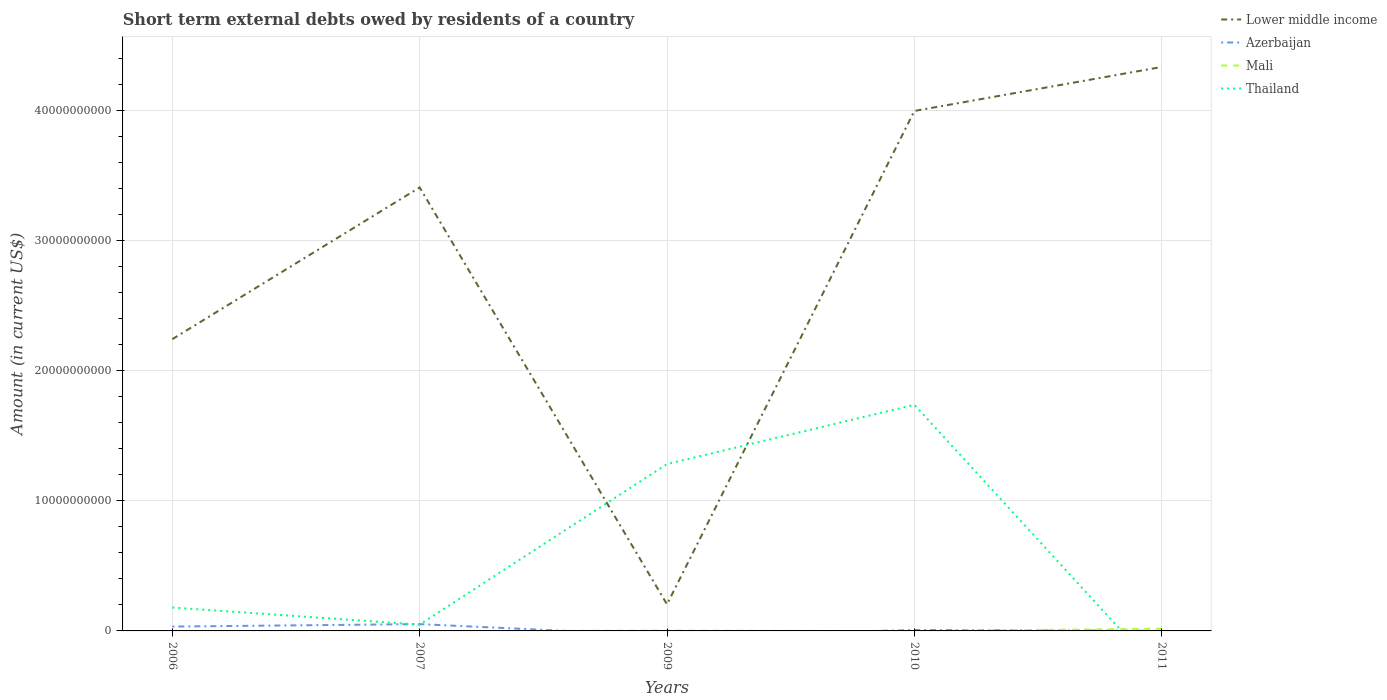How many different coloured lines are there?
Provide a short and direct response. 4. Does the line corresponding to Azerbaijan intersect with the line corresponding to Lower middle income?
Ensure brevity in your answer.  No. Is the number of lines equal to the number of legend labels?
Your answer should be compact. No. What is the total amount of short-term external debts owed by residents in Lower middle income in the graph?
Offer a terse response. 2.04e+1. What is the difference between the highest and the second highest amount of short-term external debts owed by residents in Lower middle income?
Offer a terse response. 4.13e+1. How many lines are there?
Keep it short and to the point. 4. How many years are there in the graph?
Make the answer very short. 5. Are the values on the major ticks of Y-axis written in scientific E-notation?
Offer a very short reply. No. Does the graph contain any zero values?
Your answer should be compact. Yes. How are the legend labels stacked?
Your response must be concise. Vertical. What is the title of the graph?
Your answer should be compact. Short term external debts owed by residents of a country. What is the label or title of the X-axis?
Give a very brief answer. Years. What is the label or title of the Y-axis?
Keep it short and to the point. Amount (in current US$). What is the Amount (in current US$) in Lower middle income in 2006?
Make the answer very short. 2.24e+1. What is the Amount (in current US$) in Azerbaijan in 2006?
Your answer should be compact. 3.34e+08. What is the Amount (in current US$) in Thailand in 2006?
Your answer should be compact. 1.80e+09. What is the Amount (in current US$) in Lower middle income in 2007?
Ensure brevity in your answer.  3.41e+1. What is the Amount (in current US$) of Azerbaijan in 2007?
Offer a very short reply. 5.23e+08. What is the Amount (in current US$) of Thailand in 2007?
Ensure brevity in your answer.  4.83e+08. What is the Amount (in current US$) in Lower middle income in 2009?
Provide a succinct answer. 2.04e+09. What is the Amount (in current US$) in Mali in 2009?
Provide a short and direct response. 2.40e+07. What is the Amount (in current US$) in Thailand in 2009?
Offer a very short reply. 1.28e+1. What is the Amount (in current US$) in Lower middle income in 2010?
Offer a very short reply. 4.00e+1. What is the Amount (in current US$) in Azerbaijan in 2010?
Keep it short and to the point. 6.80e+07. What is the Amount (in current US$) of Mali in 2010?
Give a very brief answer. 0. What is the Amount (in current US$) of Thailand in 2010?
Offer a terse response. 1.74e+1. What is the Amount (in current US$) of Lower middle income in 2011?
Give a very brief answer. 4.33e+1. What is the Amount (in current US$) of Azerbaijan in 2011?
Your answer should be very brief. 1.30e+07. What is the Amount (in current US$) in Mali in 2011?
Offer a very short reply. 1.69e+08. Across all years, what is the maximum Amount (in current US$) of Lower middle income?
Make the answer very short. 4.33e+1. Across all years, what is the maximum Amount (in current US$) of Azerbaijan?
Provide a succinct answer. 5.23e+08. Across all years, what is the maximum Amount (in current US$) in Mali?
Your answer should be compact. 1.69e+08. Across all years, what is the maximum Amount (in current US$) in Thailand?
Provide a succinct answer. 1.74e+1. Across all years, what is the minimum Amount (in current US$) of Lower middle income?
Your answer should be very brief. 2.04e+09. Across all years, what is the minimum Amount (in current US$) in Mali?
Offer a very short reply. 0. Across all years, what is the minimum Amount (in current US$) of Thailand?
Your response must be concise. 0. What is the total Amount (in current US$) of Lower middle income in the graph?
Your answer should be very brief. 1.42e+11. What is the total Amount (in current US$) in Azerbaijan in the graph?
Ensure brevity in your answer.  9.38e+08. What is the total Amount (in current US$) in Mali in the graph?
Give a very brief answer. 1.93e+08. What is the total Amount (in current US$) in Thailand in the graph?
Your answer should be very brief. 3.25e+1. What is the difference between the Amount (in current US$) of Lower middle income in 2006 and that in 2007?
Provide a succinct answer. -1.17e+1. What is the difference between the Amount (in current US$) of Azerbaijan in 2006 and that in 2007?
Your answer should be very brief. -1.89e+08. What is the difference between the Amount (in current US$) in Thailand in 2006 and that in 2007?
Provide a short and direct response. 1.32e+09. What is the difference between the Amount (in current US$) of Lower middle income in 2006 and that in 2009?
Provide a succinct answer. 2.04e+1. What is the difference between the Amount (in current US$) in Thailand in 2006 and that in 2009?
Offer a terse response. -1.10e+1. What is the difference between the Amount (in current US$) of Lower middle income in 2006 and that in 2010?
Make the answer very short. -1.75e+1. What is the difference between the Amount (in current US$) in Azerbaijan in 2006 and that in 2010?
Ensure brevity in your answer.  2.66e+08. What is the difference between the Amount (in current US$) in Thailand in 2006 and that in 2010?
Give a very brief answer. -1.56e+1. What is the difference between the Amount (in current US$) of Lower middle income in 2006 and that in 2011?
Provide a short and direct response. -2.09e+1. What is the difference between the Amount (in current US$) in Azerbaijan in 2006 and that in 2011?
Offer a terse response. 3.21e+08. What is the difference between the Amount (in current US$) in Lower middle income in 2007 and that in 2009?
Your response must be concise. 3.20e+1. What is the difference between the Amount (in current US$) in Thailand in 2007 and that in 2009?
Make the answer very short. -1.23e+1. What is the difference between the Amount (in current US$) of Lower middle income in 2007 and that in 2010?
Give a very brief answer. -5.88e+09. What is the difference between the Amount (in current US$) in Azerbaijan in 2007 and that in 2010?
Make the answer very short. 4.55e+08. What is the difference between the Amount (in current US$) in Thailand in 2007 and that in 2010?
Your answer should be compact. -1.69e+1. What is the difference between the Amount (in current US$) of Lower middle income in 2007 and that in 2011?
Keep it short and to the point. -9.26e+09. What is the difference between the Amount (in current US$) of Azerbaijan in 2007 and that in 2011?
Make the answer very short. 5.10e+08. What is the difference between the Amount (in current US$) of Lower middle income in 2009 and that in 2010?
Offer a very short reply. -3.79e+1. What is the difference between the Amount (in current US$) in Thailand in 2009 and that in 2010?
Provide a short and direct response. -4.55e+09. What is the difference between the Amount (in current US$) of Lower middle income in 2009 and that in 2011?
Your answer should be very brief. -4.13e+1. What is the difference between the Amount (in current US$) of Mali in 2009 and that in 2011?
Offer a very short reply. -1.45e+08. What is the difference between the Amount (in current US$) of Lower middle income in 2010 and that in 2011?
Give a very brief answer. -3.38e+09. What is the difference between the Amount (in current US$) in Azerbaijan in 2010 and that in 2011?
Your answer should be very brief. 5.50e+07. What is the difference between the Amount (in current US$) of Lower middle income in 2006 and the Amount (in current US$) of Azerbaijan in 2007?
Provide a succinct answer. 2.19e+1. What is the difference between the Amount (in current US$) in Lower middle income in 2006 and the Amount (in current US$) in Thailand in 2007?
Your answer should be very brief. 2.19e+1. What is the difference between the Amount (in current US$) in Azerbaijan in 2006 and the Amount (in current US$) in Thailand in 2007?
Provide a succinct answer. -1.49e+08. What is the difference between the Amount (in current US$) in Lower middle income in 2006 and the Amount (in current US$) in Mali in 2009?
Keep it short and to the point. 2.24e+1. What is the difference between the Amount (in current US$) in Lower middle income in 2006 and the Amount (in current US$) in Thailand in 2009?
Provide a short and direct response. 9.60e+09. What is the difference between the Amount (in current US$) in Azerbaijan in 2006 and the Amount (in current US$) in Mali in 2009?
Ensure brevity in your answer.  3.10e+08. What is the difference between the Amount (in current US$) of Azerbaijan in 2006 and the Amount (in current US$) of Thailand in 2009?
Your answer should be very brief. -1.25e+1. What is the difference between the Amount (in current US$) in Lower middle income in 2006 and the Amount (in current US$) in Azerbaijan in 2010?
Give a very brief answer. 2.24e+1. What is the difference between the Amount (in current US$) in Lower middle income in 2006 and the Amount (in current US$) in Thailand in 2010?
Give a very brief answer. 5.05e+09. What is the difference between the Amount (in current US$) in Azerbaijan in 2006 and the Amount (in current US$) in Thailand in 2010?
Offer a very short reply. -1.70e+1. What is the difference between the Amount (in current US$) of Lower middle income in 2006 and the Amount (in current US$) of Azerbaijan in 2011?
Provide a succinct answer. 2.24e+1. What is the difference between the Amount (in current US$) in Lower middle income in 2006 and the Amount (in current US$) in Mali in 2011?
Provide a short and direct response. 2.23e+1. What is the difference between the Amount (in current US$) in Azerbaijan in 2006 and the Amount (in current US$) in Mali in 2011?
Your answer should be very brief. 1.65e+08. What is the difference between the Amount (in current US$) of Lower middle income in 2007 and the Amount (in current US$) of Mali in 2009?
Provide a succinct answer. 3.41e+1. What is the difference between the Amount (in current US$) of Lower middle income in 2007 and the Amount (in current US$) of Thailand in 2009?
Ensure brevity in your answer.  2.13e+1. What is the difference between the Amount (in current US$) of Azerbaijan in 2007 and the Amount (in current US$) of Mali in 2009?
Give a very brief answer. 4.99e+08. What is the difference between the Amount (in current US$) of Azerbaijan in 2007 and the Amount (in current US$) of Thailand in 2009?
Provide a succinct answer. -1.23e+1. What is the difference between the Amount (in current US$) of Lower middle income in 2007 and the Amount (in current US$) of Azerbaijan in 2010?
Your answer should be compact. 3.40e+1. What is the difference between the Amount (in current US$) in Lower middle income in 2007 and the Amount (in current US$) in Thailand in 2010?
Ensure brevity in your answer.  1.67e+1. What is the difference between the Amount (in current US$) of Azerbaijan in 2007 and the Amount (in current US$) of Thailand in 2010?
Give a very brief answer. -1.69e+1. What is the difference between the Amount (in current US$) of Lower middle income in 2007 and the Amount (in current US$) of Azerbaijan in 2011?
Your answer should be compact. 3.41e+1. What is the difference between the Amount (in current US$) in Lower middle income in 2007 and the Amount (in current US$) in Mali in 2011?
Offer a terse response. 3.39e+1. What is the difference between the Amount (in current US$) of Azerbaijan in 2007 and the Amount (in current US$) of Mali in 2011?
Offer a terse response. 3.54e+08. What is the difference between the Amount (in current US$) in Lower middle income in 2009 and the Amount (in current US$) in Azerbaijan in 2010?
Provide a short and direct response. 1.97e+09. What is the difference between the Amount (in current US$) of Lower middle income in 2009 and the Amount (in current US$) of Thailand in 2010?
Give a very brief answer. -1.53e+1. What is the difference between the Amount (in current US$) of Mali in 2009 and the Amount (in current US$) of Thailand in 2010?
Ensure brevity in your answer.  -1.74e+1. What is the difference between the Amount (in current US$) in Lower middle income in 2009 and the Amount (in current US$) in Azerbaijan in 2011?
Give a very brief answer. 2.03e+09. What is the difference between the Amount (in current US$) in Lower middle income in 2009 and the Amount (in current US$) in Mali in 2011?
Your answer should be compact. 1.87e+09. What is the difference between the Amount (in current US$) of Lower middle income in 2010 and the Amount (in current US$) of Azerbaijan in 2011?
Ensure brevity in your answer.  4.00e+1. What is the difference between the Amount (in current US$) of Lower middle income in 2010 and the Amount (in current US$) of Mali in 2011?
Ensure brevity in your answer.  3.98e+1. What is the difference between the Amount (in current US$) in Azerbaijan in 2010 and the Amount (in current US$) in Mali in 2011?
Your response must be concise. -1.01e+08. What is the average Amount (in current US$) of Lower middle income per year?
Your response must be concise. 2.84e+1. What is the average Amount (in current US$) in Azerbaijan per year?
Your answer should be very brief. 1.88e+08. What is the average Amount (in current US$) in Mali per year?
Offer a terse response. 3.86e+07. What is the average Amount (in current US$) of Thailand per year?
Your answer should be very brief. 6.50e+09. In the year 2006, what is the difference between the Amount (in current US$) in Lower middle income and Amount (in current US$) in Azerbaijan?
Your answer should be very brief. 2.21e+1. In the year 2006, what is the difference between the Amount (in current US$) of Lower middle income and Amount (in current US$) of Thailand?
Provide a succinct answer. 2.06e+1. In the year 2006, what is the difference between the Amount (in current US$) of Azerbaijan and Amount (in current US$) of Thailand?
Ensure brevity in your answer.  -1.46e+09. In the year 2007, what is the difference between the Amount (in current US$) in Lower middle income and Amount (in current US$) in Azerbaijan?
Ensure brevity in your answer.  3.36e+1. In the year 2007, what is the difference between the Amount (in current US$) in Lower middle income and Amount (in current US$) in Thailand?
Provide a succinct answer. 3.36e+1. In the year 2007, what is the difference between the Amount (in current US$) of Azerbaijan and Amount (in current US$) of Thailand?
Your response must be concise. 4.00e+07. In the year 2009, what is the difference between the Amount (in current US$) in Lower middle income and Amount (in current US$) in Mali?
Ensure brevity in your answer.  2.02e+09. In the year 2009, what is the difference between the Amount (in current US$) of Lower middle income and Amount (in current US$) of Thailand?
Make the answer very short. -1.08e+1. In the year 2009, what is the difference between the Amount (in current US$) of Mali and Amount (in current US$) of Thailand?
Provide a succinct answer. -1.28e+1. In the year 2010, what is the difference between the Amount (in current US$) in Lower middle income and Amount (in current US$) in Azerbaijan?
Offer a terse response. 3.99e+1. In the year 2010, what is the difference between the Amount (in current US$) of Lower middle income and Amount (in current US$) of Thailand?
Your response must be concise. 2.26e+1. In the year 2010, what is the difference between the Amount (in current US$) of Azerbaijan and Amount (in current US$) of Thailand?
Your answer should be very brief. -1.73e+1. In the year 2011, what is the difference between the Amount (in current US$) of Lower middle income and Amount (in current US$) of Azerbaijan?
Ensure brevity in your answer.  4.33e+1. In the year 2011, what is the difference between the Amount (in current US$) of Lower middle income and Amount (in current US$) of Mali?
Provide a succinct answer. 4.32e+1. In the year 2011, what is the difference between the Amount (in current US$) in Azerbaijan and Amount (in current US$) in Mali?
Provide a succinct answer. -1.56e+08. What is the ratio of the Amount (in current US$) of Lower middle income in 2006 to that in 2007?
Your answer should be very brief. 0.66. What is the ratio of the Amount (in current US$) in Azerbaijan in 2006 to that in 2007?
Offer a very short reply. 0.64. What is the ratio of the Amount (in current US$) of Thailand in 2006 to that in 2007?
Offer a very short reply. 3.72. What is the ratio of the Amount (in current US$) in Lower middle income in 2006 to that in 2009?
Keep it short and to the point. 10.99. What is the ratio of the Amount (in current US$) of Thailand in 2006 to that in 2009?
Provide a short and direct response. 0.14. What is the ratio of the Amount (in current US$) in Lower middle income in 2006 to that in 2010?
Offer a terse response. 0.56. What is the ratio of the Amount (in current US$) of Azerbaijan in 2006 to that in 2010?
Offer a terse response. 4.91. What is the ratio of the Amount (in current US$) in Thailand in 2006 to that in 2010?
Your answer should be very brief. 0.1. What is the ratio of the Amount (in current US$) of Lower middle income in 2006 to that in 2011?
Give a very brief answer. 0.52. What is the ratio of the Amount (in current US$) of Azerbaijan in 2006 to that in 2011?
Ensure brevity in your answer.  25.69. What is the ratio of the Amount (in current US$) in Lower middle income in 2007 to that in 2009?
Your answer should be very brief. 16.7. What is the ratio of the Amount (in current US$) of Thailand in 2007 to that in 2009?
Make the answer very short. 0.04. What is the ratio of the Amount (in current US$) of Lower middle income in 2007 to that in 2010?
Keep it short and to the point. 0.85. What is the ratio of the Amount (in current US$) of Azerbaijan in 2007 to that in 2010?
Ensure brevity in your answer.  7.69. What is the ratio of the Amount (in current US$) in Thailand in 2007 to that in 2010?
Offer a terse response. 0.03. What is the ratio of the Amount (in current US$) in Lower middle income in 2007 to that in 2011?
Your response must be concise. 0.79. What is the ratio of the Amount (in current US$) in Azerbaijan in 2007 to that in 2011?
Give a very brief answer. 40.23. What is the ratio of the Amount (in current US$) of Lower middle income in 2009 to that in 2010?
Your answer should be very brief. 0.05. What is the ratio of the Amount (in current US$) in Thailand in 2009 to that in 2010?
Offer a terse response. 0.74. What is the ratio of the Amount (in current US$) in Lower middle income in 2009 to that in 2011?
Offer a terse response. 0.05. What is the ratio of the Amount (in current US$) of Mali in 2009 to that in 2011?
Your response must be concise. 0.14. What is the ratio of the Amount (in current US$) of Lower middle income in 2010 to that in 2011?
Offer a very short reply. 0.92. What is the ratio of the Amount (in current US$) in Azerbaijan in 2010 to that in 2011?
Ensure brevity in your answer.  5.23. What is the difference between the highest and the second highest Amount (in current US$) in Lower middle income?
Your answer should be compact. 3.38e+09. What is the difference between the highest and the second highest Amount (in current US$) in Azerbaijan?
Your answer should be compact. 1.89e+08. What is the difference between the highest and the second highest Amount (in current US$) in Thailand?
Your answer should be very brief. 4.55e+09. What is the difference between the highest and the lowest Amount (in current US$) in Lower middle income?
Your response must be concise. 4.13e+1. What is the difference between the highest and the lowest Amount (in current US$) in Azerbaijan?
Make the answer very short. 5.23e+08. What is the difference between the highest and the lowest Amount (in current US$) in Mali?
Offer a very short reply. 1.69e+08. What is the difference between the highest and the lowest Amount (in current US$) of Thailand?
Offer a very short reply. 1.74e+1. 